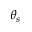Convert formula to latex. <formula><loc_0><loc_0><loc_500><loc_500>\theta _ { s }</formula> 